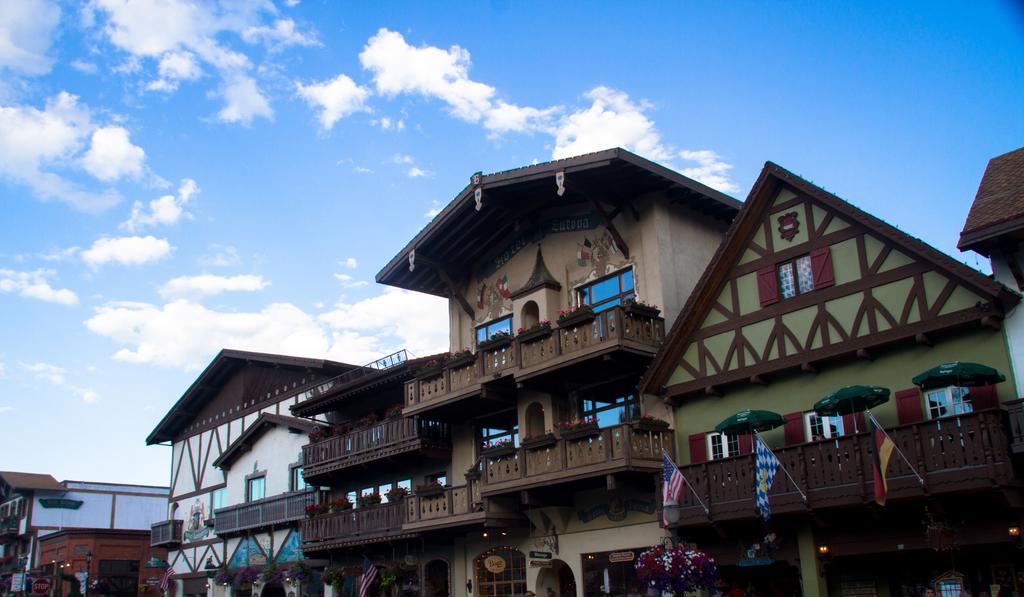Please provide a concise description of this image. In this image there are buildings one beside the other. On the right side there are flags attached to the building. At the top there is the sky. At the bottom there are flower plants. There are three umbrellas in the balcony. There are lights below the building. 